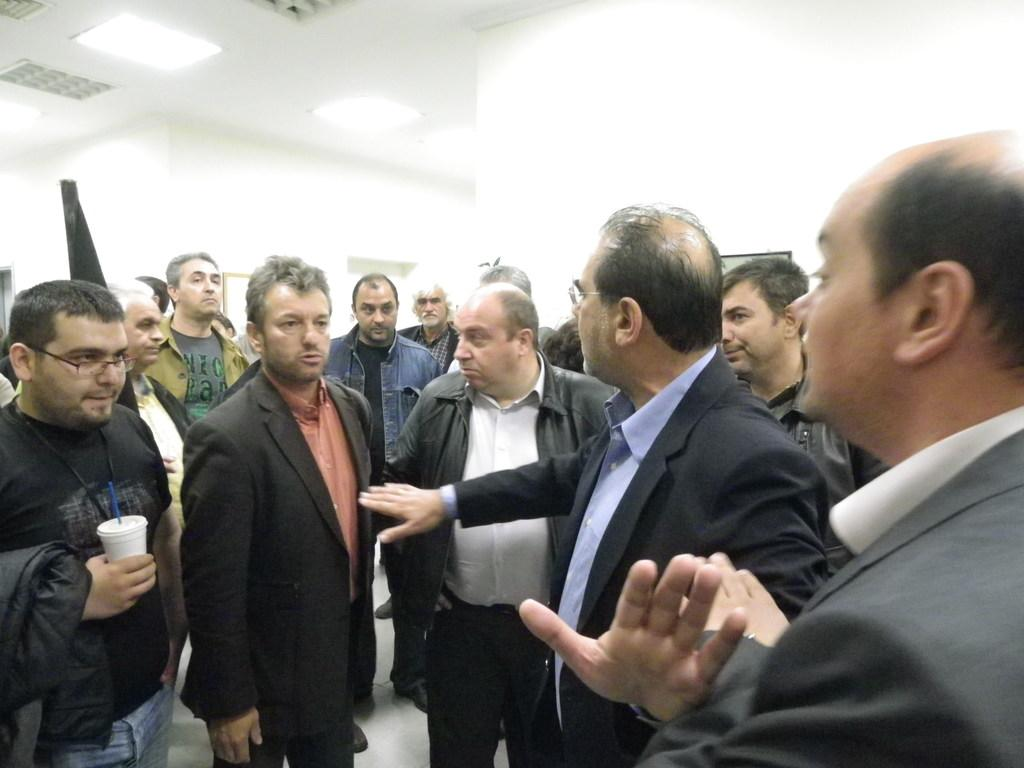How many people are in the group visible in the image? There is a group of people in the image, but the exact number cannot be determined without more specific information. What is visible in the background of the image? There is a wall, lights, and a ceiling visible in the background of the image. What type of earth can be seen in the image? There is no earth or soil present in the image; it features a group of people and background elements. What is the plot of the story being told in the image? The image does not depict a story or narrative, so it is not possible to determine the plot. 